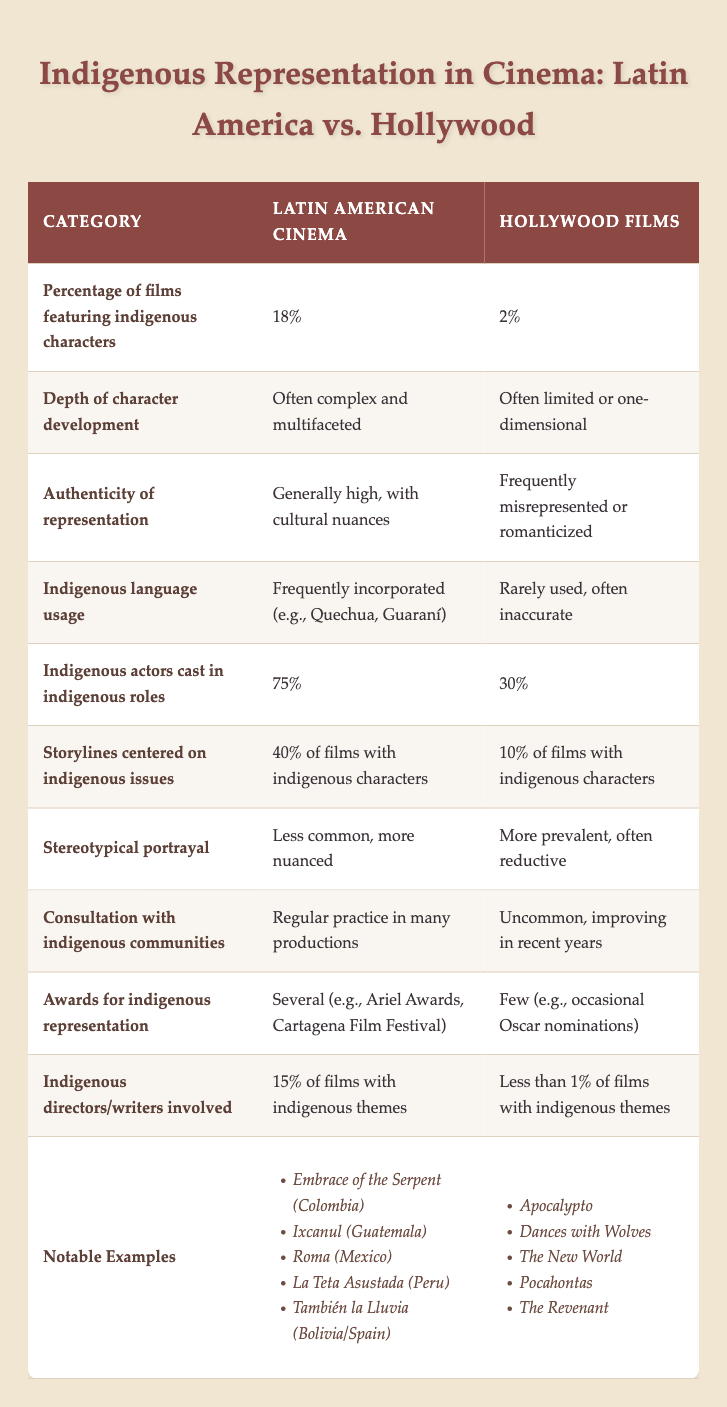What percentage of films feature indigenous characters in Hollywood films? According to the table, Hollywood films have a percentage of only 2% featuring indigenous characters, as clearly stated in the relevant row.
Answer: 2% How many films with indigenous characters in Latin American cinema center on indigenous issues? The table shows that 40% of films with indigenous characters in Latin American cinema focus on indigenous issues, referenced in the corresponding row.
Answer: 40% Is the use of indigenous languages more common in Latin American cinema or Hollywood films? Looking at the table, it indicates that indigenous languages are frequently incorporated in Latin American cinema, while in Hollywood films, they are rarely used. This clearly demonstrates that Latin American cinema has a higher usage of indigenous languages.
Answer: Latin American cinema What is the difference in percentage of indigenous actors cast in indigenous roles between Latin American cinema and Hollywood films? The table shows that 75% of actors in Latin American cinema are indigenous, compared to 30% in Hollywood films. The difference is calculated as 75% - 30% = 45%.
Answer: 45% Do Hollywood films often represent indigenous characters complexly? By examining the table, it states that Hollywood films often portray indigenous characters in a limited or one-dimensional manner, verifying the response to the question as false.
Answer: No What is the average percentage of films with indigenous characters focusing on indigenous issues in both Latin American cinema and Hollywood films? From the table, Latin American cinema has 40% while Hollywood movies have 10%. To find the average, we sum the percentages (40% + 10% = 50%) and divide by 2, resulting in an average of 25%.
Answer: 25% Are there more awards for indigenous representation in Latin American cinema compared to Hollywood films? The table indicates that Latin American cinema has several awards for indigenous representation, whereas Hollywood films have few. This clearly shows that Latin American cinema has more awards.
Answer: Yes How many notable examples are listed for each cinema type? The table shows that there are 5 notable examples for Latin American cinema and 5 for Hollywood films. Both counts are equal, thus confirming the number of examples per category.
Answer: 5 